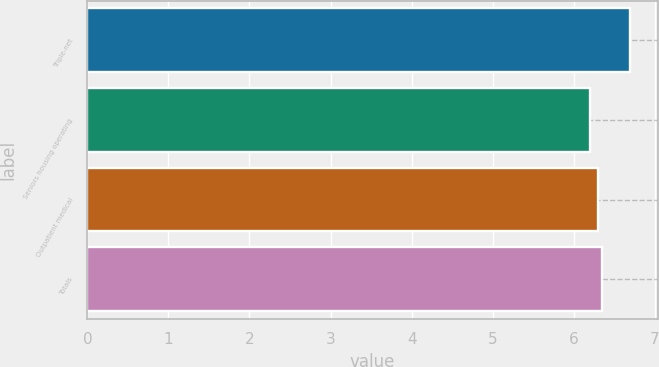<chart> <loc_0><loc_0><loc_500><loc_500><bar_chart><fcel>Triple-net<fcel>Seniors housing operating<fcel>Outpatient medical<fcel>Totals<nl><fcel>6.7<fcel>6.2<fcel>6.3<fcel>6.35<nl></chart> 